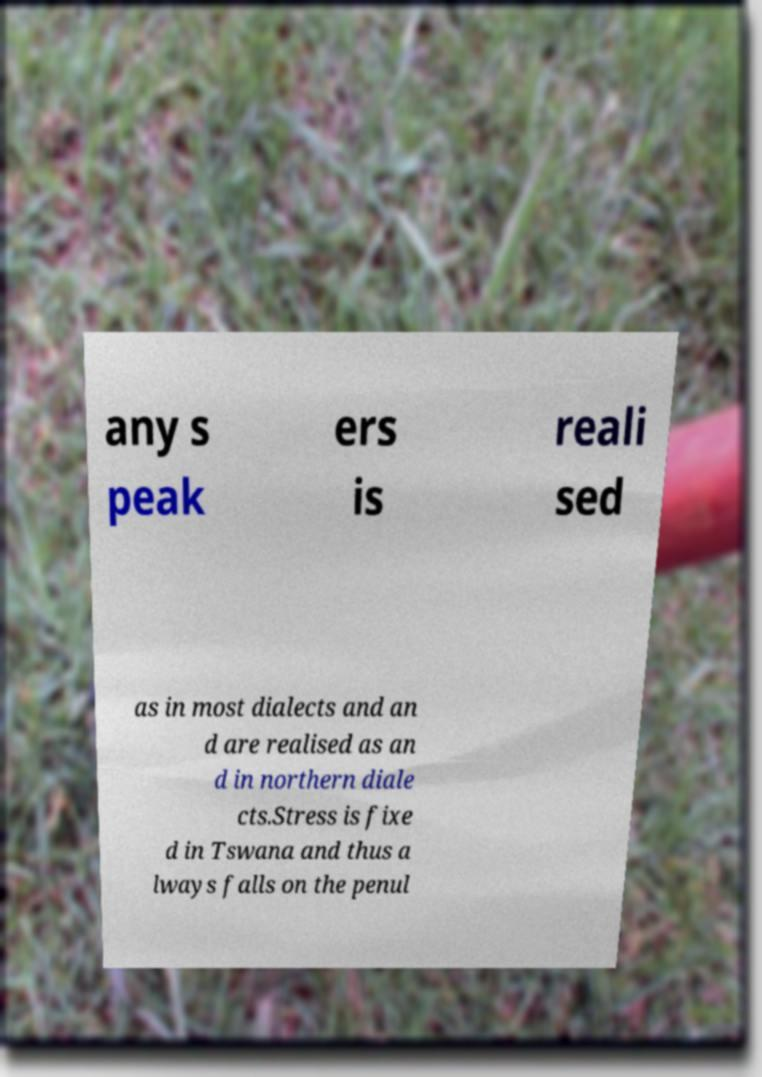I need the written content from this picture converted into text. Can you do that? any s peak ers is reali sed as in most dialects and an d are realised as an d in northern diale cts.Stress is fixe d in Tswana and thus a lways falls on the penul 